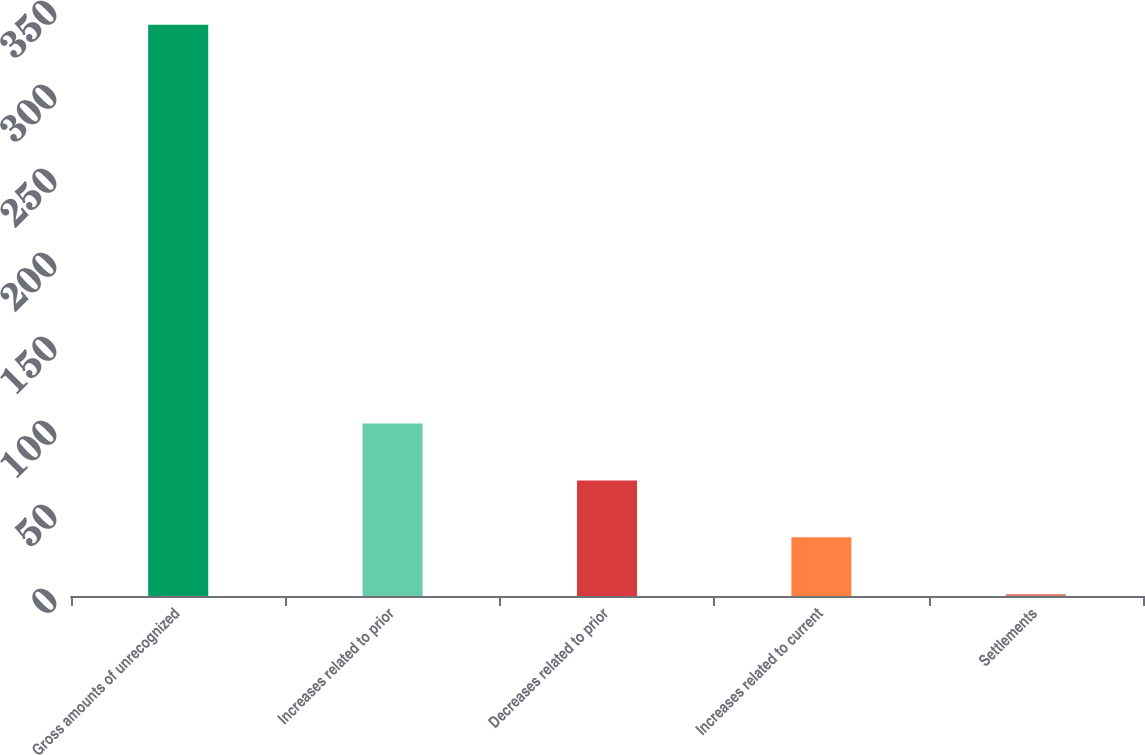Convert chart to OTSL. <chart><loc_0><loc_0><loc_500><loc_500><bar_chart><fcel>Gross amounts of unrecognized<fcel>Increases related to prior<fcel>Decreases related to prior<fcel>Increases related to current<fcel>Settlements<nl><fcel>340<fcel>102.7<fcel>68.8<fcel>34.9<fcel>1<nl></chart> 